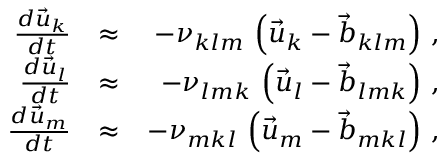Convert formula to latex. <formula><loc_0><loc_0><loc_500><loc_500>\begin{array} { r l r } { \frac { d \vec { u } _ { k } } { d t } } & { \approx } & { - \nu _ { k l m } \, \left ( \vec { u } _ { k } - \vec { b } _ { k l m } \right ) \, , } \\ { \frac { d \vec { u } _ { l } } { d t } } & { \approx } & { - \nu _ { l m k } \, \left ( \vec { u } _ { l } - \vec { b } _ { l m k } \right ) \, , } \\ { \frac { d \vec { u } _ { m } } { d t } } & { \approx } & { - \nu _ { m k l } \, \left ( \vec { u } _ { m } - \vec { b } _ { m k l } \right ) \, , } \end{array}</formula> 